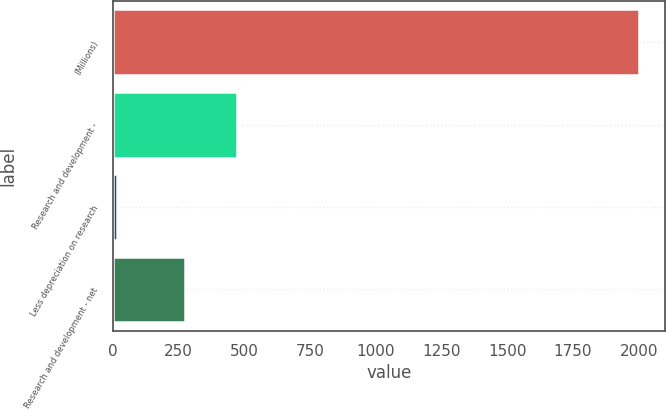<chart> <loc_0><loc_0><loc_500><loc_500><bar_chart><fcel>(Millions)<fcel>Research and development -<fcel>Less depreciation on research<fcel>Research and development - net<nl><fcel>2002<fcel>471.6<fcel>16<fcel>273<nl></chart> 